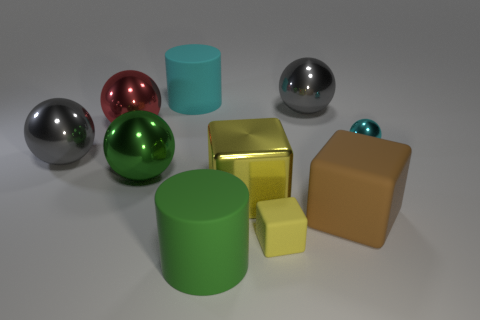Is there anything in the image that suggests it might not be a real-life photograph? Yes, upon closer examination, the perfection in the objects' shapes and the evenness of the lighting could imply that this image is a computer-generated rendering rather than a photograph. 